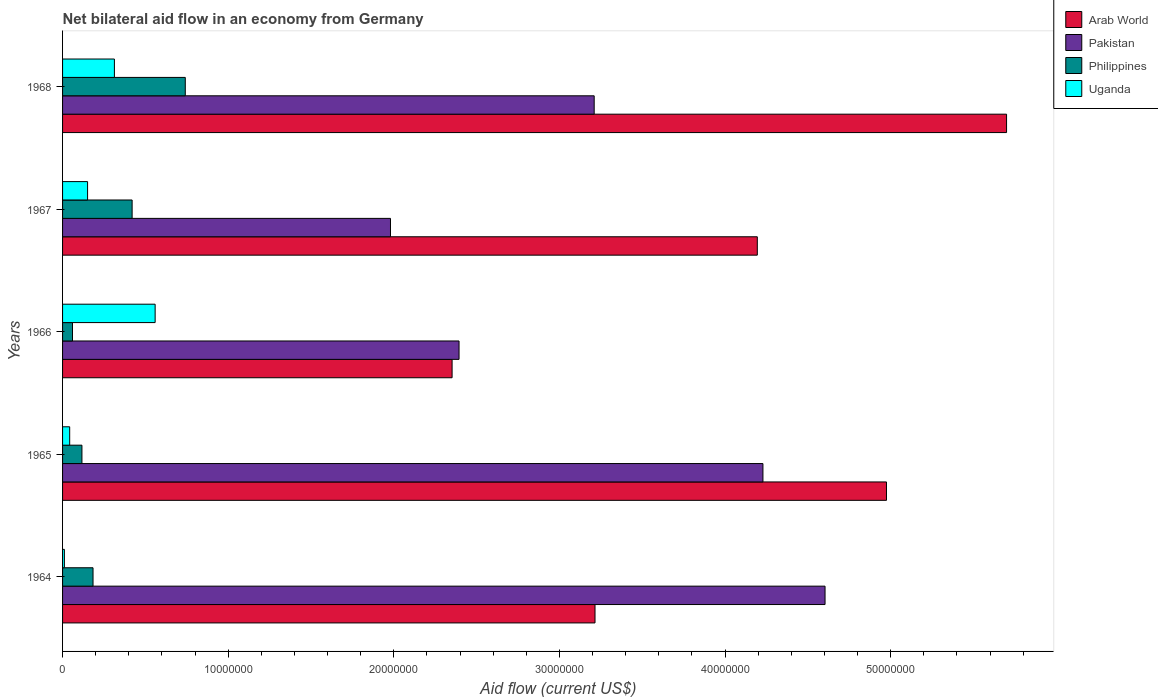Are the number of bars per tick equal to the number of legend labels?
Your answer should be very brief. Yes. How many bars are there on the 2nd tick from the top?
Provide a succinct answer. 4. What is the label of the 2nd group of bars from the top?
Provide a succinct answer. 1967. What is the net bilateral aid flow in Pakistan in 1968?
Provide a short and direct response. 3.21e+07. Across all years, what is the maximum net bilateral aid flow in Pakistan?
Offer a terse response. 4.60e+07. Across all years, what is the minimum net bilateral aid flow in Pakistan?
Your response must be concise. 1.98e+07. In which year was the net bilateral aid flow in Uganda maximum?
Ensure brevity in your answer.  1966. In which year was the net bilateral aid flow in Philippines minimum?
Provide a short and direct response. 1966. What is the total net bilateral aid flow in Philippines in the graph?
Offer a very short reply. 1.52e+07. What is the difference between the net bilateral aid flow in Pakistan in 1966 and that in 1968?
Make the answer very short. -8.16e+06. What is the difference between the net bilateral aid flow in Philippines in 1964 and the net bilateral aid flow in Arab World in 1965?
Make the answer very short. -4.79e+07. What is the average net bilateral aid flow in Pakistan per year?
Offer a terse response. 3.28e+07. In the year 1967, what is the difference between the net bilateral aid flow in Arab World and net bilateral aid flow in Pakistan?
Keep it short and to the point. 2.22e+07. In how many years, is the net bilateral aid flow in Philippines greater than 6000000 US$?
Keep it short and to the point. 1. What is the ratio of the net bilateral aid flow in Uganda in 1964 to that in 1967?
Provide a succinct answer. 0.07. Is the difference between the net bilateral aid flow in Arab World in 1964 and 1967 greater than the difference between the net bilateral aid flow in Pakistan in 1964 and 1967?
Provide a short and direct response. No. What is the difference between the highest and the second highest net bilateral aid flow in Pakistan?
Provide a short and direct response. 3.75e+06. What is the difference between the highest and the lowest net bilateral aid flow in Arab World?
Your answer should be very brief. 3.35e+07. In how many years, is the net bilateral aid flow in Pakistan greater than the average net bilateral aid flow in Pakistan taken over all years?
Make the answer very short. 2. Is the sum of the net bilateral aid flow in Philippines in 1965 and 1967 greater than the maximum net bilateral aid flow in Uganda across all years?
Offer a terse response. No. Is it the case that in every year, the sum of the net bilateral aid flow in Arab World and net bilateral aid flow in Uganda is greater than the sum of net bilateral aid flow in Pakistan and net bilateral aid flow in Philippines?
Offer a terse response. No. What does the 4th bar from the top in 1966 represents?
Your answer should be very brief. Arab World. What does the 1st bar from the bottom in 1968 represents?
Your response must be concise. Arab World. How many bars are there?
Ensure brevity in your answer.  20. Are the values on the major ticks of X-axis written in scientific E-notation?
Give a very brief answer. No. Does the graph contain any zero values?
Provide a short and direct response. No. Does the graph contain grids?
Provide a short and direct response. No. How are the legend labels stacked?
Make the answer very short. Vertical. What is the title of the graph?
Your answer should be compact. Net bilateral aid flow in an economy from Germany. What is the Aid flow (current US$) in Arab World in 1964?
Your answer should be compact. 3.22e+07. What is the Aid flow (current US$) of Pakistan in 1964?
Ensure brevity in your answer.  4.60e+07. What is the Aid flow (current US$) in Philippines in 1964?
Give a very brief answer. 1.84e+06. What is the Aid flow (current US$) of Uganda in 1964?
Your answer should be very brief. 1.10e+05. What is the Aid flow (current US$) in Arab World in 1965?
Your response must be concise. 4.98e+07. What is the Aid flow (current US$) of Pakistan in 1965?
Your answer should be compact. 4.23e+07. What is the Aid flow (current US$) of Philippines in 1965?
Offer a terse response. 1.17e+06. What is the Aid flow (current US$) in Uganda in 1965?
Ensure brevity in your answer.  4.30e+05. What is the Aid flow (current US$) in Arab World in 1966?
Offer a very short reply. 2.35e+07. What is the Aid flow (current US$) of Pakistan in 1966?
Your answer should be compact. 2.39e+07. What is the Aid flow (current US$) of Uganda in 1966?
Give a very brief answer. 5.59e+06. What is the Aid flow (current US$) of Arab World in 1967?
Your answer should be very brief. 4.20e+07. What is the Aid flow (current US$) of Pakistan in 1967?
Offer a very short reply. 1.98e+07. What is the Aid flow (current US$) of Philippines in 1967?
Ensure brevity in your answer.  4.20e+06. What is the Aid flow (current US$) of Uganda in 1967?
Provide a short and direct response. 1.51e+06. What is the Aid flow (current US$) in Arab World in 1968?
Give a very brief answer. 5.70e+07. What is the Aid flow (current US$) of Pakistan in 1968?
Keep it short and to the point. 3.21e+07. What is the Aid flow (current US$) of Philippines in 1968?
Your response must be concise. 7.41e+06. What is the Aid flow (current US$) of Uganda in 1968?
Give a very brief answer. 3.13e+06. Across all years, what is the maximum Aid flow (current US$) in Arab World?
Offer a very short reply. 5.70e+07. Across all years, what is the maximum Aid flow (current US$) in Pakistan?
Offer a terse response. 4.60e+07. Across all years, what is the maximum Aid flow (current US$) of Philippines?
Keep it short and to the point. 7.41e+06. Across all years, what is the maximum Aid flow (current US$) in Uganda?
Provide a short and direct response. 5.59e+06. Across all years, what is the minimum Aid flow (current US$) of Arab World?
Give a very brief answer. 2.35e+07. Across all years, what is the minimum Aid flow (current US$) in Pakistan?
Make the answer very short. 1.98e+07. What is the total Aid flow (current US$) in Arab World in the graph?
Offer a very short reply. 2.04e+08. What is the total Aid flow (current US$) of Pakistan in the graph?
Keep it short and to the point. 1.64e+08. What is the total Aid flow (current US$) in Philippines in the graph?
Ensure brevity in your answer.  1.52e+07. What is the total Aid flow (current US$) in Uganda in the graph?
Ensure brevity in your answer.  1.08e+07. What is the difference between the Aid flow (current US$) of Arab World in 1964 and that in 1965?
Your answer should be very brief. -1.76e+07. What is the difference between the Aid flow (current US$) in Pakistan in 1964 and that in 1965?
Your response must be concise. 3.75e+06. What is the difference between the Aid flow (current US$) of Philippines in 1964 and that in 1965?
Make the answer very short. 6.70e+05. What is the difference between the Aid flow (current US$) in Uganda in 1964 and that in 1965?
Your answer should be very brief. -3.20e+05. What is the difference between the Aid flow (current US$) in Arab World in 1964 and that in 1966?
Your answer should be compact. 8.63e+06. What is the difference between the Aid flow (current US$) of Pakistan in 1964 and that in 1966?
Your answer should be compact. 2.21e+07. What is the difference between the Aid flow (current US$) in Philippines in 1964 and that in 1966?
Your response must be concise. 1.24e+06. What is the difference between the Aid flow (current US$) of Uganda in 1964 and that in 1966?
Offer a very short reply. -5.48e+06. What is the difference between the Aid flow (current US$) of Arab World in 1964 and that in 1967?
Your response must be concise. -9.80e+06. What is the difference between the Aid flow (current US$) in Pakistan in 1964 and that in 1967?
Offer a terse response. 2.62e+07. What is the difference between the Aid flow (current US$) in Philippines in 1964 and that in 1967?
Ensure brevity in your answer.  -2.36e+06. What is the difference between the Aid flow (current US$) of Uganda in 1964 and that in 1967?
Provide a succinct answer. -1.40e+06. What is the difference between the Aid flow (current US$) of Arab World in 1964 and that in 1968?
Your response must be concise. -2.48e+07. What is the difference between the Aid flow (current US$) of Pakistan in 1964 and that in 1968?
Provide a succinct answer. 1.39e+07. What is the difference between the Aid flow (current US$) in Philippines in 1964 and that in 1968?
Provide a short and direct response. -5.57e+06. What is the difference between the Aid flow (current US$) of Uganda in 1964 and that in 1968?
Give a very brief answer. -3.02e+06. What is the difference between the Aid flow (current US$) of Arab World in 1965 and that in 1966?
Provide a succinct answer. 2.62e+07. What is the difference between the Aid flow (current US$) in Pakistan in 1965 and that in 1966?
Your answer should be compact. 1.84e+07. What is the difference between the Aid flow (current US$) of Philippines in 1965 and that in 1966?
Offer a terse response. 5.70e+05. What is the difference between the Aid flow (current US$) in Uganda in 1965 and that in 1966?
Ensure brevity in your answer.  -5.16e+06. What is the difference between the Aid flow (current US$) of Arab World in 1965 and that in 1967?
Make the answer very short. 7.80e+06. What is the difference between the Aid flow (current US$) in Pakistan in 1965 and that in 1967?
Your answer should be very brief. 2.25e+07. What is the difference between the Aid flow (current US$) of Philippines in 1965 and that in 1967?
Your response must be concise. -3.03e+06. What is the difference between the Aid flow (current US$) in Uganda in 1965 and that in 1967?
Provide a succinct answer. -1.08e+06. What is the difference between the Aid flow (current US$) of Arab World in 1965 and that in 1968?
Your answer should be compact. -7.25e+06. What is the difference between the Aid flow (current US$) of Pakistan in 1965 and that in 1968?
Give a very brief answer. 1.02e+07. What is the difference between the Aid flow (current US$) of Philippines in 1965 and that in 1968?
Give a very brief answer. -6.24e+06. What is the difference between the Aid flow (current US$) of Uganda in 1965 and that in 1968?
Your answer should be compact. -2.70e+06. What is the difference between the Aid flow (current US$) of Arab World in 1966 and that in 1967?
Provide a short and direct response. -1.84e+07. What is the difference between the Aid flow (current US$) of Pakistan in 1966 and that in 1967?
Ensure brevity in your answer.  4.14e+06. What is the difference between the Aid flow (current US$) of Philippines in 1966 and that in 1967?
Offer a terse response. -3.60e+06. What is the difference between the Aid flow (current US$) in Uganda in 1966 and that in 1967?
Offer a terse response. 4.08e+06. What is the difference between the Aid flow (current US$) in Arab World in 1966 and that in 1968?
Provide a short and direct response. -3.35e+07. What is the difference between the Aid flow (current US$) in Pakistan in 1966 and that in 1968?
Make the answer very short. -8.16e+06. What is the difference between the Aid flow (current US$) of Philippines in 1966 and that in 1968?
Keep it short and to the point. -6.81e+06. What is the difference between the Aid flow (current US$) of Uganda in 1966 and that in 1968?
Your response must be concise. 2.46e+06. What is the difference between the Aid flow (current US$) of Arab World in 1967 and that in 1968?
Make the answer very short. -1.50e+07. What is the difference between the Aid flow (current US$) in Pakistan in 1967 and that in 1968?
Ensure brevity in your answer.  -1.23e+07. What is the difference between the Aid flow (current US$) of Philippines in 1967 and that in 1968?
Make the answer very short. -3.21e+06. What is the difference between the Aid flow (current US$) of Uganda in 1967 and that in 1968?
Keep it short and to the point. -1.62e+06. What is the difference between the Aid flow (current US$) in Arab World in 1964 and the Aid flow (current US$) in Pakistan in 1965?
Ensure brevity in your answer.  -1.01e+07. What is the difference between the Aid flow (current US$) of Arab World in 1964 and the Aid flow (current US$) of Philippines in 1965?
Offer a very short reply. 3.10e+07. What is the difference between the Aid flow (current US$) in Arab World in 1964 and the Aid flow (current US$) in Uganda in 1965?
Make the answer very short. 3.17e+07. What is the difference between the Aid flow (current US$) in Pakistan in 1964 and the Aid flow (current US$) in Philippines in 1965?
Offer a terse response. 4.49e+07. What is the difference between the Aid flow (current US$) in Pakistan in 1964 and the Aid flow (current US$) in Uganda in 1965?
Make the answer very short. 4.56e+07. What is the difference between the Aid flow (current US$) of Philippines in 1964 and the Aid flow (current US$) of Uganda in 1965?
Your answer should be very brief. 1.41e+06. What is the difference between the Aid flow (current US$) in Arab World in 1964 and the Aid flow (current US$) in Pakistan in 1966?
Provide a short and direct response. 8.21e+06. What is the difference between the Aid flow (current US$) of Arab World in 1964 and the Aid flow (current US$) of Philippines in 1966?
Your answer should be very brief. 3.16e+07. What is the difference between the Aid flow (current US$) in Arab World in 1964 and the Aid flow (current US$) in Uganda in 1966?
Your answer should be compact. 2.66e+07. What is the difference between the Aid flow (current US$) in Pakistan in 1964 and the Aid flow (current US$) in Philippines in 1966?
Provide a short and direct response. 4.54e+07. What is the difference between the Aid flow (current US$) in Pakistan in 1964 and the Aid flow (current US$) in Uganda in 1966?
Ensure brevity in your answer.  4.04e+07. What is the difference between the Aid flow (current US$) in Philippines in 1964 and the Aid flow (current US$) in Uganda in 1966?
Keep it short and to the point. -3.75e+06. What is the difference between the Aid flow (current US$) in Arab World in 1964 and the Aid flow (current US$) in Pakistan in 1967?
Give a very brief answer. 1.24e+07. What is the difference between the Aid flow (current US$) in Arab World in 1964 and the Aid flow (current US$) in Philippines in 1967?
Keep it short and to the point. 2.80e+07. What is the difference between the Aid flow (current US$) in Arab World in 1964 and the Aid flow (current US$) in Uganda in 1967?
Ensure brevity in your answer.  3.06e+07. What is the difference between the Aid flow (current US$) in Pakistan in 1964 and the Aid flow (current US$) in Philippines in 1967?
Provide a short and direct response. 4.18e+07. What is the difference between the Aid flow (current US$) of Pakistan in 1964 and the Aid flow (current US$) of Uganda in 1967?
Provide a short and direct response. 4.45e+07. What is the difference between the Aid flow (current US$) of Philippines in 1964 and the Aid flow (current US$) of Uganda in 1967?
Your answer should be very brief. 3.30e+05. What is the difference between the Aid flow (current US$) in Arab World in 1964 and the Aid flow (current US$) in Pakistan in 1968?
Keep it short and to the point. 5.00e+04. What is the difference between the Aid flow (current US$) of Arab World in 1964 and the Aid flow (current US$) of Philippines in 1968?
Give a very brief answer. 2.47e+07. What is the difference between the Aid flow (current US$) in Arab World in 1964 and the Aid flow (current US$) in Uganda in 1968?
Keep it short and to the point. 2.90e+07. What is the difference between the Aid flow (current US$) of Pakistan in 1964 and the Aid flow (current US$) of Philippines in 1968?
Your answer should be compact. 3.86e+07. What is the difference between the Aid flow (current US$) in Pakistan in 1964 and the Aid flow (current US$) in Uganda in 1968?
Make the answer very short. 4.29e+07. What is the difference between the Aid flow (current US$) of Philippines in 1964 and the Aid flow (current US$) of Uganda in 1968?
Your response must be concise. -1.29e+06. What is the difference between the Aid flow (current US$) of Arab World in 1965 and the Aid flow (current US$) of Pakistan in 1966?
Ensure brevity in your answer.  2.58e+07. What is the difference between the Aid flow (current US$) in Arab World in 1965 and the Aid flow (current US$) in Philippines in 1966?
Offer a very short reply. 4.92e+07. What is the difference between the Aid flow (current US$) of Arab World in 1965 and the Aid flow (current US$) of Uganda in 1966?
Offer a terse response. 4.42e+07. What is the difference between the Aid flow (current US$) in Pakistan in 1965 and the Aid flow (current US$) in Philippines in 1966?
Ensure brevity in your answer.  4.17e+07. What is the difference between the Aid flow (current US$) of Pakistan in 1965 and the Aid flow (current US$) of Uganda in 1966?
Make the answer very short. 3.67e+07. What is the difference between the Aid flow (current US$) of Philippines in 1965 and the Aid flow (current US$) of Uganda in 1966?
Offer a terse response. -4.42e+06. What is the difference between the Aid flow (current US$) of Arab World in 1965 and the Aid flow (current US$) of Pakistan in 1967?
Provide a short and direct response. 3.00e+07. What is the difference between the Aid flow (current US$) of Arab World in 1965 and the Aid flow (current US$) of Philippines in 1967?
Make the answer very short. 4.56e+07. What is the difference between the Aid flow (current US$) of Arab World in 1965 and the Aid flow (current US$) of Uganda in 1967?
Ensure brevity in your answer.  4.82e+07. What is the difference between the Aid flow (current US$) of Pakistan in 1965 and the Aid flow (current US$) of Philippines in 1967?
Give a very brief answer. 3.81e+07. What is the difference between the Aid flow (current US$) of Pakistan in 1965 and the Aid flow (current US$) of Uganda in 1967?
Offer a very short reply. 4.08e+07. What is the difference between the Aid flow (current US$) of Philippines in 1965 and the Aid flow (current US$) of Uganda in 1967?
Keep it short and to the point. -3.40e+05. What is the difference between the Aid flow (current US$) in Arab World in 1965 and the Aid flow (current US$) in Pakistan in 1968?
Your answer should be compact. 1.76e+07. What is the difference between the Aid flow (current US$) in Arab World in 1965 and the Aid flow (current US$) in Philippines in 1968?
Offer a very short reply. 4.23e+07. What is the difference between the Aid flow (current US$) of Arab World in 1965 and the Aid flow (current US$) of Uganda in 1968?
Offer a very short reply. 4.66e+07. What is the difference between the Aid flow (current US$) in Pakistan in 1965 and the Aid flow (current US$) in Philippines in 1968?
Keep it short and to the point. 3.49e+07. What is the difference between the Aid flow (current US$) in Pakistan in 1965 and the Aid flow (current US$) in Uganda in 1968?
Provide a succinct answer. 3.92e+07. What is the difference between the Aid flow (current US$) in Philippines in 1965 and the Aid flow (current US$) in Uganda in 1968?
Your answer should be very brief. -1.96e+06. What is the difference between the Aid flow (current US$) in Arab World in 1966 and the Aid flow (current US$) in Pakistan in 1967?
Offer a terse response. 3.72e+06. What is the difference between the Aid flow (current US$) of Arab World in 1966 and the Aid flow (current US$) of Philippines in 1967?
Your response must be concise. 1.93e+07. What is the difference between the Aid flow (current US$) of Arab World in 1966 and the Aid flow (current US$) of Uganda in 1967?
Provide a short and direct response. 2.20e+07. What is the difference between the Aid flow (current US$) in Pakistan in 1966 and the Aid flow (current US$) in Philippines in 1967?
Keep it short and to the point. 1.97e+07. What is the difference between the Aid flow (current US$) in Pakistan in 1966 and the Aid flow (current US$) in Uganda in 1967?
Ensure brevity in your answer.  2.24e+07. What is the difference between the Aid flow (current US$) in Philippines in 1966 and the Aid flow (current US$) in Uganda in 1967?
Provide a short and direct response. -9.10e+05. What is the difference between the Aid flow (current US$) of Arab World in 1966 and the Aid flow (current US$) of Pakistan in 1968?
Your answer should be very brief. -8.58e+06. What is the difference between the Aid flow (current US$) of Arab World in 1966 and the Aid flow (current US$) of Philippines in 1968?
Your answer should be very brief. 1.61e+07. What is the difference between the Aid flow (current US$) of Arab World in 1966 and the Aid flow (current US$) of Uganda in 1968?
Make the answer very short. 2.04e+07. What is the difference between the Aid flow (current US$) of Pakistan in 1966 and the Aid flow (current US$) of Philippines in 1968?
Offer a terse response. 1.65e+07. What is the difference between the Aid flow (current US$) in Pakistan in 1966 and the Aid flow (current US$) in Uganda in 1968?
Your response must be concise. 2.08e+07. What is the difference between the Aid flow (current US$) in Philippines in 1966 and the Aid flow (current US$) in Uganda in 1968?
Give a very brief answer. -2.53e+06. What is the difference between the Aid flow (current US$) in Arab World in 1967 and the Aid flow (current US$) in Pakistan in 1968?
Make the answer very short. 9.85e+06. What is the difference between the Aid flow (current US$) in Arab World in 1967 and the Aid flow (current US$) in Philippines in 1968?
Offer a terse response. 3.45e+07. What is the difference between the Aid flow (current US$) in Arab World in 1967 and the Aid flow (current US$) in Uganda in 1968?
Keep it short and to the point. 3.88e+07. What is the difference between the Aid flow (current US$) in Pakistan in 1967 and the Aid flow (current US$) in Philippines in 1968?
Provide a succinct answer. 1.24e+07. What is the difference between the Aid flow (current US$) of Pakistan in 1967 and the Aid flow (current US$) of Uganda in 1968?
Offer a very short reply. 1.67e+07. What is the difference between the Aid flow (current US$) of Philippines in 1967 and the Aid flow (current US$) of Uganda in 1968?
Make the answer very short. 1.07e+06. What is the average Aid flow (current US$) of Arab World per year?
Make the answer very short. 4.09e+07. What is the average Aid flow (current US$) of Pakistan per year?
Provide a succinct answer. 3.28e+07. What is the average Aid flow (current US$) in Philippines per year?
Provide a short and direct response. 3.04e+06. What is the average Aid flow (current US$) in Uganda per year?
Keep it short and to the point. 2.15e+06. In the year 1964, what is the difference between the Aid flow (current US$) in Arab World and Aid flow (current US$) in Pakistan?
Your response must be concise. -1.39e+07. In the year 1964, what is the difference between the Aid flow (current US$) of Arab World and Aid flow (current US$) of Philippines?
Ensure brevity in your answer.  3.03e+07. In the year 1964, what is the difference between the Aid flow (current US$) of Arab World and Aid flow (current US$) of Uganda?
Offer a terse response. 3.20e+07. In the year 1964, what is the difference between the Aid flow (current US$) in Pakistan and Aid flow (current US$) in Philippines?
Provide a succinct answer. 4.42e+07. In the year 1964, what is the difference between the Aid flow (current US$) in Pakistan and Aid flow (current US$) in Uganda?
Offer a very short reply. 4.59e+07. In the year 1964, what is the difference between the Aid flow (current US$) of Philippines and Aid flow (current US$) of Uganda?
Your answer should be very brief. 1.73e+06. In the year 1965, what is the difference between the Aid flow (current US$) in Arab World and Aid flow (current US$) in Pakistan?
Give a very brief answer. 7.46e+06. In the year 1965, what is the difference between the Aid flow (current US$) of Arab World and Aid flow (current US$) of Philippines?
Offer a very short reply. 4.86e+07. In the year 1965, what is the difference between the Aid flow (current US$) in Arab World and Aid flow (current US$) in Uganda?
Offer a terse response. 4.93e+07. In the year 1965, what is the difference between the Aid flow (current US$) of Pakistan and Aid flow (current US$) of Philippines?
Your answer should be very brief. 4.11e+07. In the year 1965, what is the difference between the Aid flow (current US$) in Pakistan and Aid flow (current US$) in Uganda?
Offer a terse response. 4.19e+07. In the year 1965, what is the difference between the Aid flow (current US$) in Philippines and Aid flow (current US$) in Uganda?
Offer a very short reply. 7.40e+05. In the year 1966, what is the difference between the Aid flow (current US$) of Arab World and Aid flow (current US$) of Pakistan?
Ensure brevity in your answer.  -4.20e+05. In the year 1966, what is the difference between the Aid flow (current US$) of Arab World and Aid flow (current US$) of Philippines?
Offer a terse response. 2.29e+07. In the year 1966, what is the difference between the Aid flow (current US$) in Arab World and Aid flow (current US$) in Uganda?
Your answer should be compact. 1.79e+07. In the year 1966, what is the difference between the Aid flow (current US$) of Pakistan and Aid flow (current US$) of Philippines?
Offer a very short reply. 2.33e+07. In the year 1966, what is the difference between the Aid flow (current US$) of Pakistan and Aid flow (current US$) of Uganda?
Your answer should be very brief. 1.84e+07. In the year 1966, what is the difference between the Aid flow (current US$) in Philippines and Aid flow (current US$) in Uganda?
Provide a short and direct response. -4.99e+06. In the year 1967, what is the difference between the Aid flow (current US$) in Arab World and Aid flow (current US$) in Pakistan?
Provide a short and direct response. 2.22e+07. In the year 1967, what is the difference between the Aid flow (current US$) in Arab World and Aid flow (current US$) in Philippines?
Keep it short and to the point. 3.78e+07. In the year 1967, what is the difference between the Aid flow (current US$) of Arab World and Aid flow (current US$) of Uganda?
Make the answer very short. 4.04e+07. In the year 1967, what is the difference between the Aid flow (current US$) of Pakistan and Aid flow (current US$) of Philippines?
Give a very brief answer. 1.56e+07. In the year 1967, what is the difference between the Aid flow (current US$) of Pakistan and Aid flow (current US$) of Uganda?
Make the answer very short. 1.83e+07. In the year 1967, what is the difference between the Aid flow (current US$) in Philippines and Aid flow (current US$) in Uganda?
Offer a terse response. 2.69e+06. In the year 1968, what is the difference between the Aid flow (current US$) of Arab World and Aid flow (current US$) of Pakistan?
Offer a terse response. 2.49e+07. In the year 1968, what is the difference between the Aid flow (current US$) of Arab World and Aid flow (current US$) of Philippines?
Your response must be concise. 4.96e+07. In the year 1968, what is the difference between the Aid flow (current US$) of Arab World and Aid flow (current US$) of Uganda?
Your response must be concise. 5.39e+07. In the year 1968, what is the difference between the Aid flow (current US$) in Pakistan and Aid flow (current US$) in Philippines?
Offer a terse response. 2.47e+07. In the year 1968, what is the difference between the Aid flow (current US$) in Pakistan and Aid flow (current US$) in Uganda?
Your answer should be compact. 2.90e+07. In the year 1968, what is the difference between the Aid flow (current US$) of Philippines and Aid flow (current US$) of Uganda?
Provide a succinct answer. 4.28e+06. What is the ratio of the Aid flow (current US$) of Arab World in 1964 to that in 1965?
Provide a short and direct response. 0.65. What is the ratio of the Aid flow (current US$) in Pakistan in 1964 to that in 1965?
Keep it short and to the point. 1.09. What is the ratio of the Aid flow (current US$) of Philippines in 1964 to that in 1965?
Your response must be concise. 1.57. What is the ratio of the Aid flow (current US$) in Uganda in 1964 to that in 1965?
Ensure brevity in your answer.  0.26. What is the ratio of the Aid flow (current US$) in Arab World in 1964 to that in 1966?
Provide a succinct answer. 1.37. What is the ratio of the Aid flow (current US$) of Pakistan in 1964 to that in 1966?
Offer a terse response. 1.92. What is the ratio of the Aid flow (current US$) in Philippines in 1964 to that in 1966?
Your answer should be compact. 3.07. What is the ratio of the Aid flow (current US$) in Uganda in 1964 to that in 1966?
Your answer should be very brief. 0.02. What is the ratio of the Aid flow (current US$) in Arab World in 1964 to that in 1967?
Give a very brief answer. 0.77. What is the ratio of the Aid flow (current US$) of Pakistan in 1964 to that in 1967?
Make the answer very short. 2.33. What is the ratio of the Aid flow (current US$) in Philippines in 1964 to that in 1967?
Make the answer very short. 0.44. What is the ratio of the Aid flow (current US$) of Uganda in 1964 to that in 1967?
Your answer should be very brief. 0.07. What is the ratio of the Aid flow (current US$) of Arab World in 1964 to that in 1968?
Offer a very short reply. 0.56. What is the ratio of the Aid flow (current US$) in Pakistan in 1964 to that in 1968?
Make the answer very short. 1.43. What is the ratio of the Aid flow (current US$) of Philippines in 1964 to that in 1968?
Ensure brevity in your answer.  0.25. What is the ratio of the Aid flow (current US$) in Uganda in 1964 to that in 1968?
Offer a very short reply. 0.04. What is the ratio of the Aid flow (current US$) in Arab World in 1965 to that in 1966?
Offer a very short reply. 2.12. What is the ratio of the Aid flow (current US$) in Pakistan in 1965 to that in 1966?
Your answer should be compact. 1.77. What is the ratio of the Aid flow (current US$) of Philippines in 1965 to that in 1966?
Your answer should be compact. 1.95. What is the ratio of the Aid flow (current US$) in Uganda in 1965 to that in 1966?
Provide a succinct answer. 0.08. What is the ratio of the Aid flow (current US$) in Arab World in 1965 to that in 1967?
Provide a short and direct response. 1.19. What is the ratio of the Aid flow (current US$) of Pakistan in 1965 to that in 1967?
Provide a succinct answer. 2.14. What is the ratio of the Aid flow (current US$) in Philippines in 1965 to that in 1967?
Your response must be concise. 0.28. What is the ratio of the Aid flow (current US$) in Uganda in 1965 to that in 1967?
Your response must be concise. 0.28. What is the ratio of the Aid flow (current US$) in Arab World in 1965 to that in 1968?
Your answer should be very brief. 0.87. What is the ratio of the Aid flow (current US$) of Pakistan in 1965 to that in 1968?
Offer a terse response. 1.32. What is the ratio of the Aid flow (current US$) in Philippines in 1965 to that in 1968?
Provide a succinct answer. 0.16. What is the ratio of the Aid flow (current US$) in Uganda in 1965 to that in 1968?
Your answer should be compact. 0.14. What is the ratio of the Aid flow (current US$) of Arab World in 1966 to that in 1967?
Provide a succinct answer. 0.56. What is the ratio of the Aid flow (current US$) in Pakistan in 1966 to that in 1967?
Your answer should be compact. 1.21. What is the ratio of the Aid flow (current US$) in Philippines in 1966 to that in 1967?
Provide a succinct answer. 0.14. What is the ratio of the Aid flow (current US$) of Uganda in 1966 to that in 1967?
Your answer should be compact. 3.7. What is the ratio of the Aid flow (current US$) of Arab World in 1966 to that in 1968?
Your answer should be compact. 0.41. What is the ratio of the Aid flow (current US$) in Pakistan in 1966 to that in 1968?
Make the answer very short. 0.75. What is the ratio of the Aid flow (current US$) in Philippines in 1966 to that in 1968?
Ensure brevity in your answer.  0.08. What is the ratio of the Aid flow (current US$) of Uganda in 1966 to that in 1968?
Make the answer very short. 1.79. What is the ratio of the Aid flow (current US$) of Arab World in 1967 to that in 1968?
Your answer should be very brief. 0.74. What is the ratio of the Aid flow (current US$) in Pakistan in 1967 to that in 1968?
Give a very brief answer. 0.62. What is the ratio of the Aid flow (current US$) of Philippines in 1967 to that in 1968?
Provide a succinct answer. 0.57. What is the ratio of the Aid flow (current US$) of Uganda in 1967 to that in 1968?
Keep it short and to the point. 0.48. What is the difference between the highest and the second highest Aid flow (current US$) in Arab World?
Make the answer very short. 7.25e+06. What is the difference between the highest and the second highest Aid flow (current US$) of Pakistan?
Provide a short and direct response. 3.75e+06. What is the difference between the highest and the second highest Aid flow (current US$) in Philippines?
Keep it short and to the point. 3.21e+06. What is the difference between the highest and the second highest Aid flow (current US$) of Uganda?
Offer a terse response. 2.46e+06. What is the difference between the highest and the lowest Aid flow (current US$) of Arab World?
Your response must be concise. 3.35e+07. What is the difference between the highest and the lowest Aid flow (current US$) of Pakistan?
Make the answer very short. 2.62e+07. What is the difference between the highest and the lowest Aid flow (current US$) in Philippines?
Offer a terse response. 6.81e+06. What is the difference between the highest and the lowest Aid flow (current US$) in Uganda?
Your answer should be compact. 5.48e+06. 